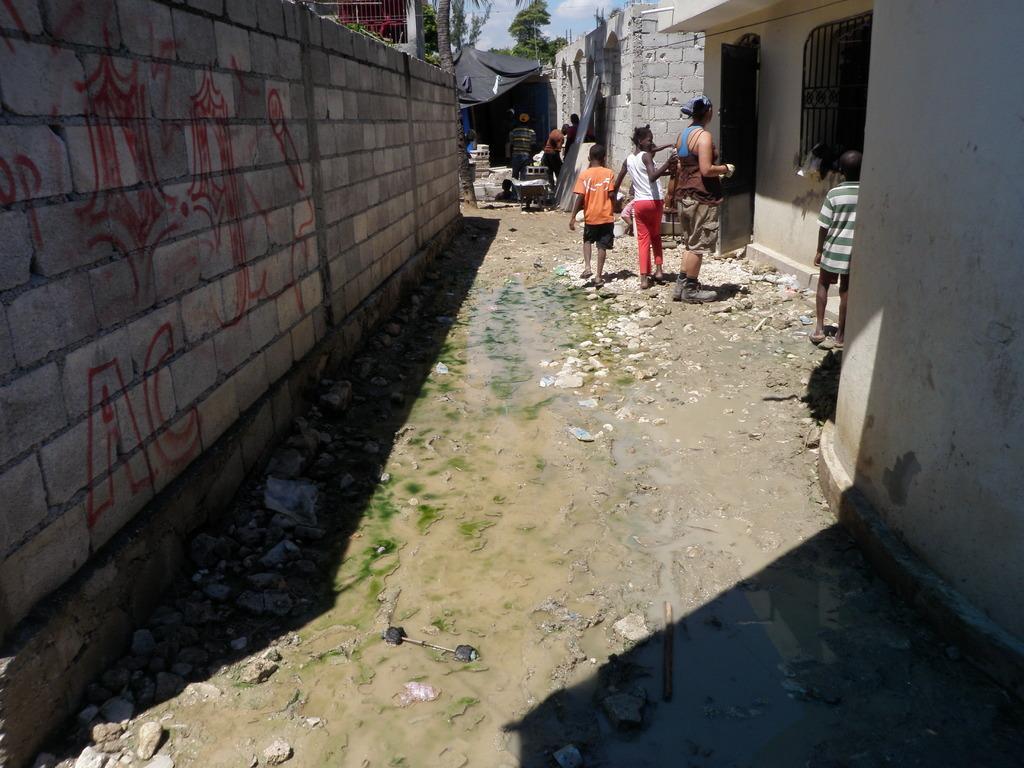Can you describe this image briefly? In this image there are people walking on the ground in between compound wall and building, also there is a tree at the back. 